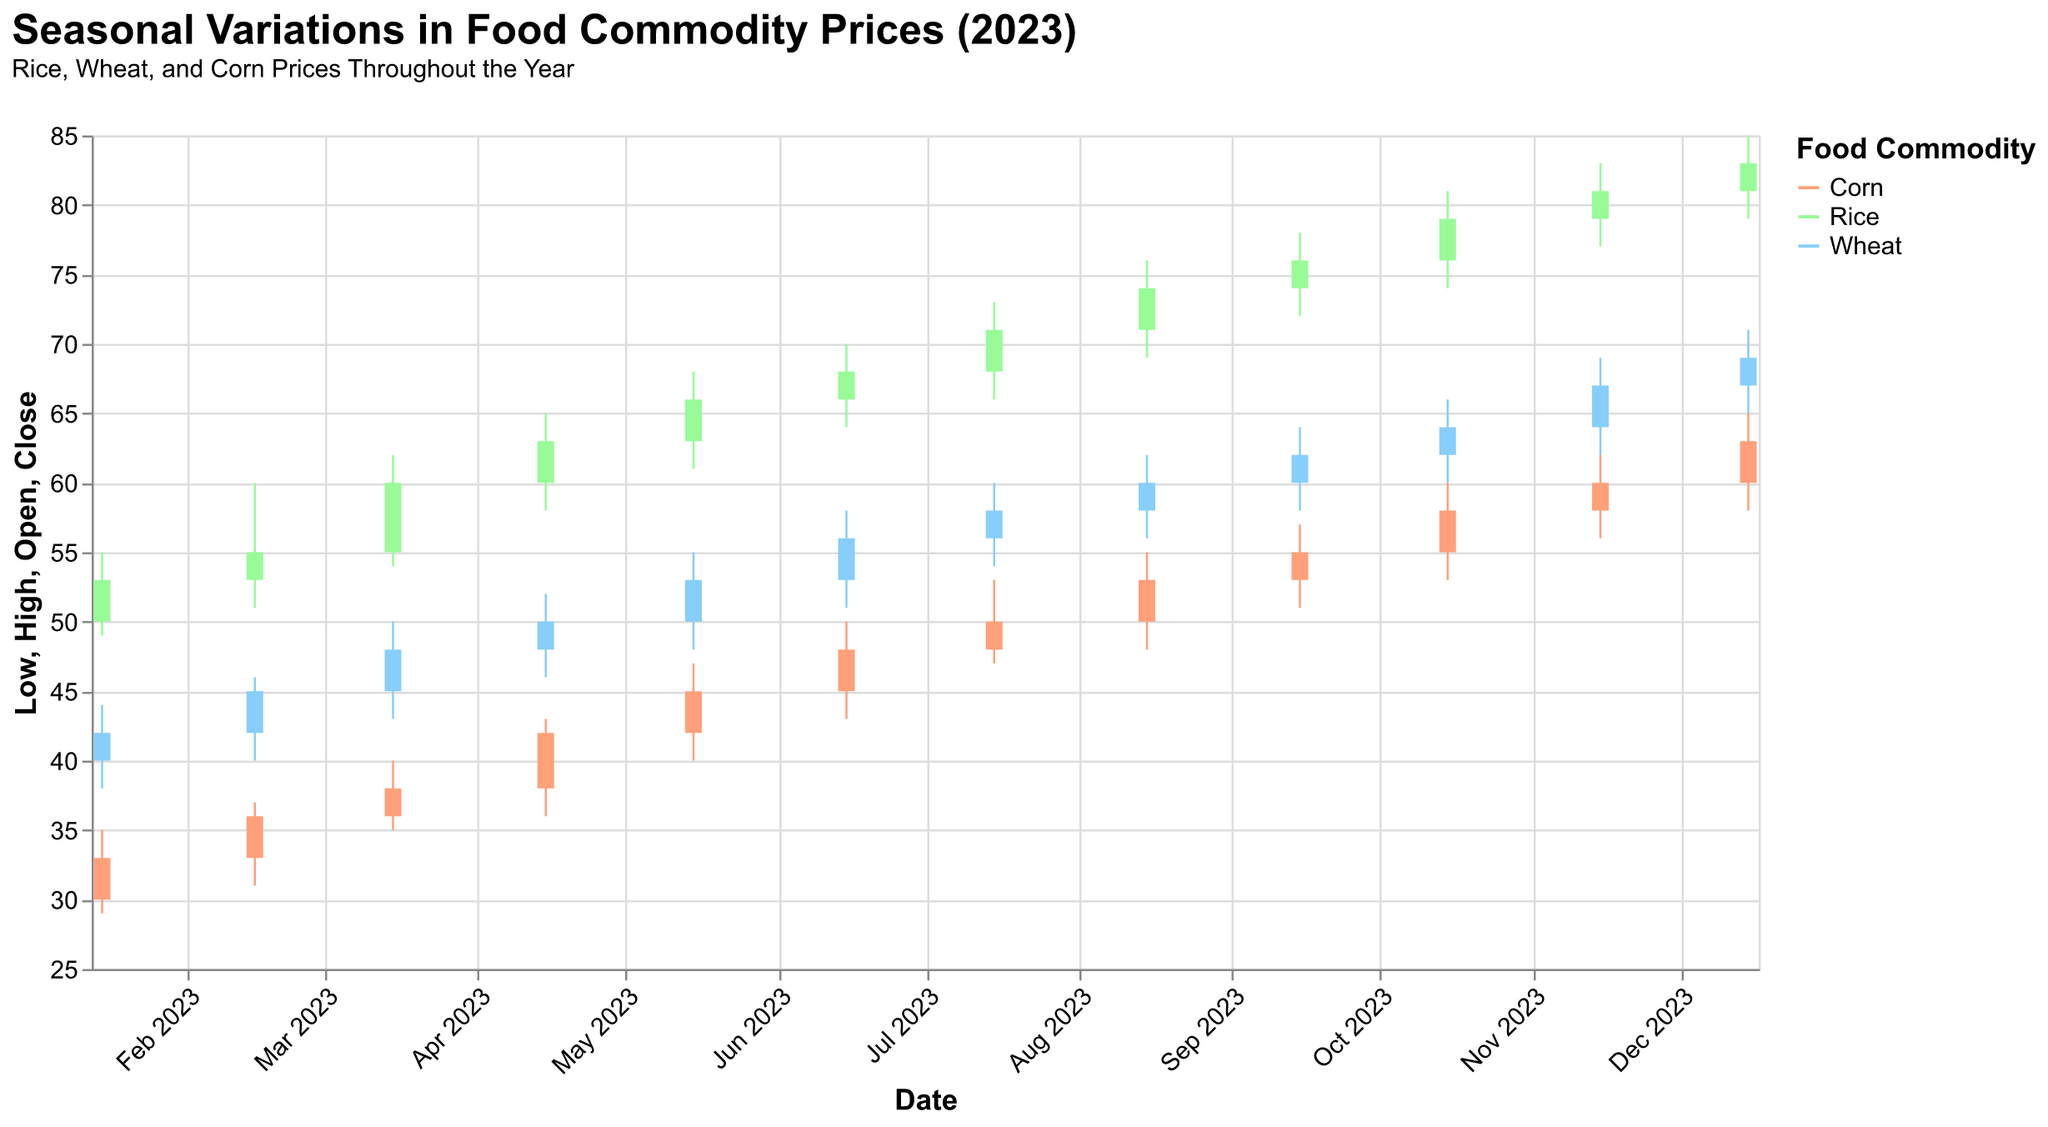What is the general trend of rice prices throughout the year? By observing the candlestick for rice over the months, it is clear that the prices generally increase. Starting at a low of 50 in January and closing at 83 in December, rice prices show a consistent upward trend.
Answer: Increasing What is the highest closing price for wheat and in which month does it occur? The plot shows the highest closing price for wheat is 69, occurring in December.
Answer: 69, December Which food commodity shows the greatest increase in price from January to December? To find the greatest increase, compare the January and December closing prices for each commodity. Rice goes from 53 to 83 (+30), Wheat from 42 to 69 (+27), and Corn from 33 to 63 (+30). Both Rice and Corn show an equal greatest increase of 30.
Answer: Rice and Corn What was the closing price for corn in June and how does it compare to January? The closing price for corn in June is 48, and in January it is 33. Therefore, June’s price is 48 - 33 = 15 points higher than January's.
Answer: 15 points higher In which months did all the commodities (rice, wheat, and corn) see a rise in their closing prices compared to the previous month? By comparing month-over-month changes: February (all rise), March (all rise), April, May, July, etc. All commodities rise in February, March, and May (compared to previous months).
Answer: February, March, May Between August and October, which commodity shows the most volatility? Volatility can be assessed by the range between high and low prices. For Rice: 69-76, 72-78, 74-81; Wheat: 56-62, 58-64, 60-66; Corn: 48-55, 51-57, 53-60. Calculate the ranges, Rice (7, 6, 7), Wheat (6, 6, 6), Corn (7, 6, 7). All have similar ranges but Rice's prices have the slight edge with exact 7 in two months.
Answer: Rice What is the average closing price of wheat over the whole year? Add all closing prices of wheat: 42+45+48+50+53+56+58+60+62+64+67+69 = 674. Divide by 12 months: 674/12 = 56.17.
Answer: 56.17 During which month does corn show its largest single-month price increase? Compare month-over-month price differences: February (36-33 = 3), March (38-36 = 2), April (42-38 = 4), May (45-42 = 3), June (48-45 = 3), July (50-48 = 2), August (53-50 = 3), September (55-53 = 2), October (58-55 = 3), November (60-58 = 2), December (63-60 = 3). The largest single increase is April with 4.
Answer: April How does the closing price range of the three commodities compare in July? Rice: 66 to 73, Wheat: 54 to 60, Corn: 47 to 53. Calculate ranges: Rice = 7, Wheat = 6, Corn = 6
Answer: Rice has the largest range Which commodity experienced the greatest percentage increase in closing price from January to December? Calculate percentage increases: Rice ((83-53)/53)*100 = 56.60%, Wheat ((69-42)/42)*100 = 64.29%, Corn ((63-33)/33)*100 = 90.91%. Corn has the highest percentage increase.
Answer: Corn 